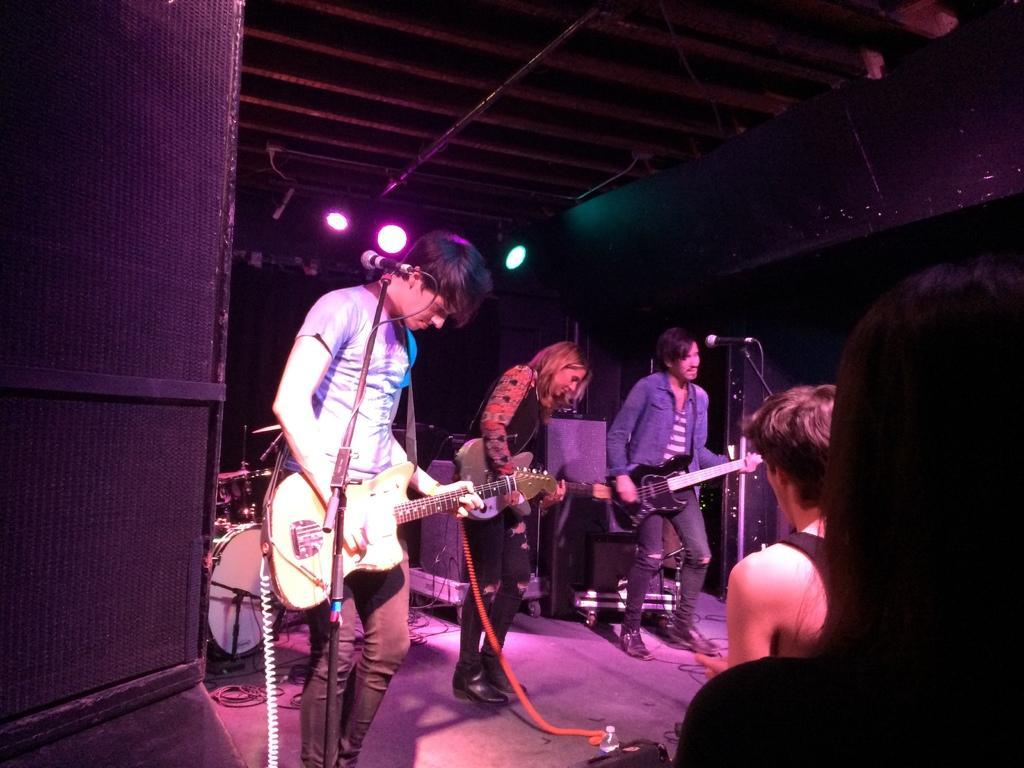What is the man in the image doing? The man is playing a guitar. What is the man positioned near in the image? The man is in front of a microphone. What can be seen above the man in the image? There are lights visible over the roof. What is the relationship between the man and the people in the image? There are people in front of the man, suggesting they might be an audience or fellow performers. What type of drain is visible in the image? There is no drain present in the image. 